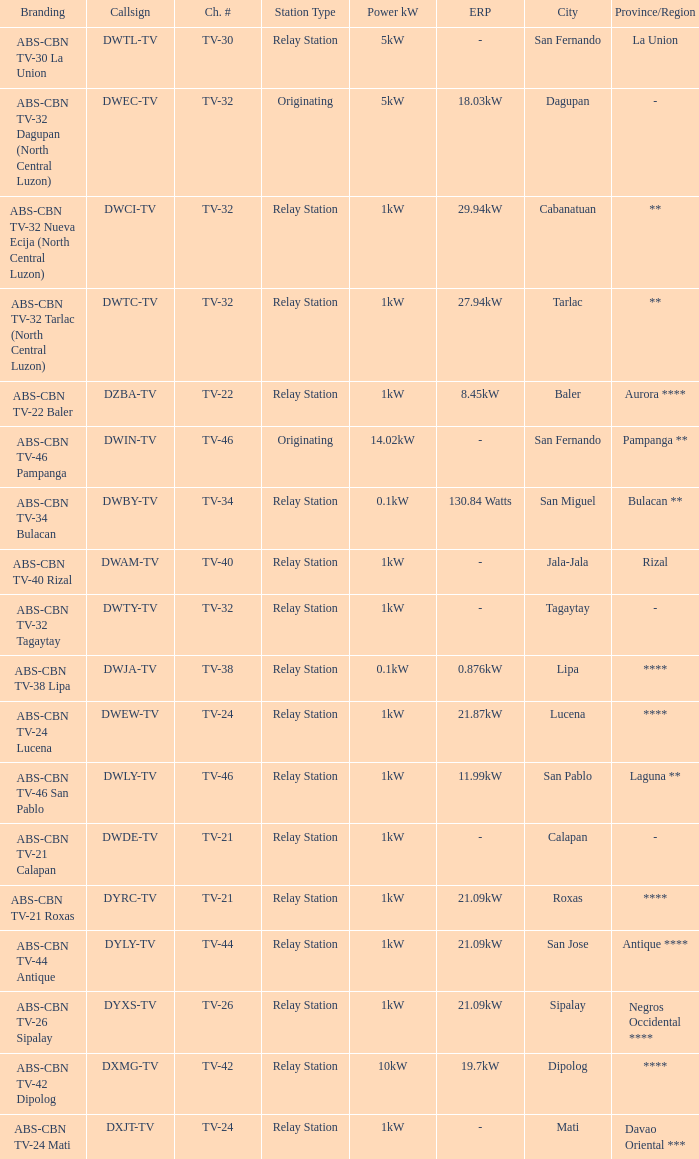What is the branding of the callsign DWCI-TV? ABS-CBN TV-32 Nueva Ecija (North Central Luzon). 